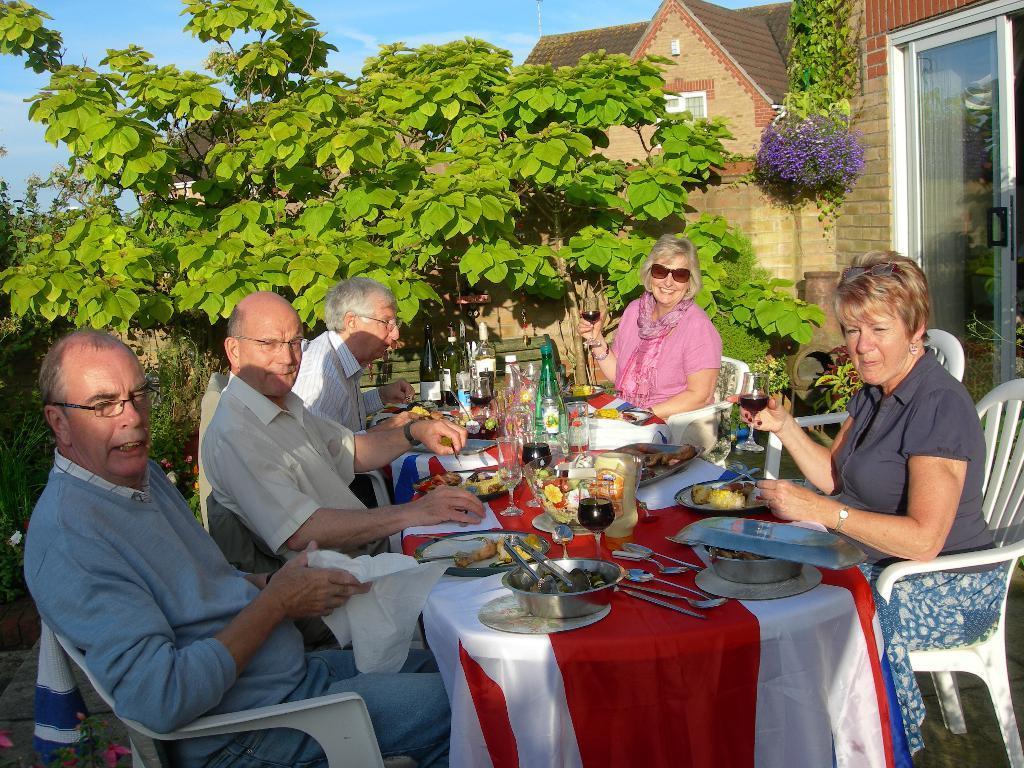Please provide a concise description of this image. There are group of people sitting around the table and eating food in it. behind then there are trees and building. 